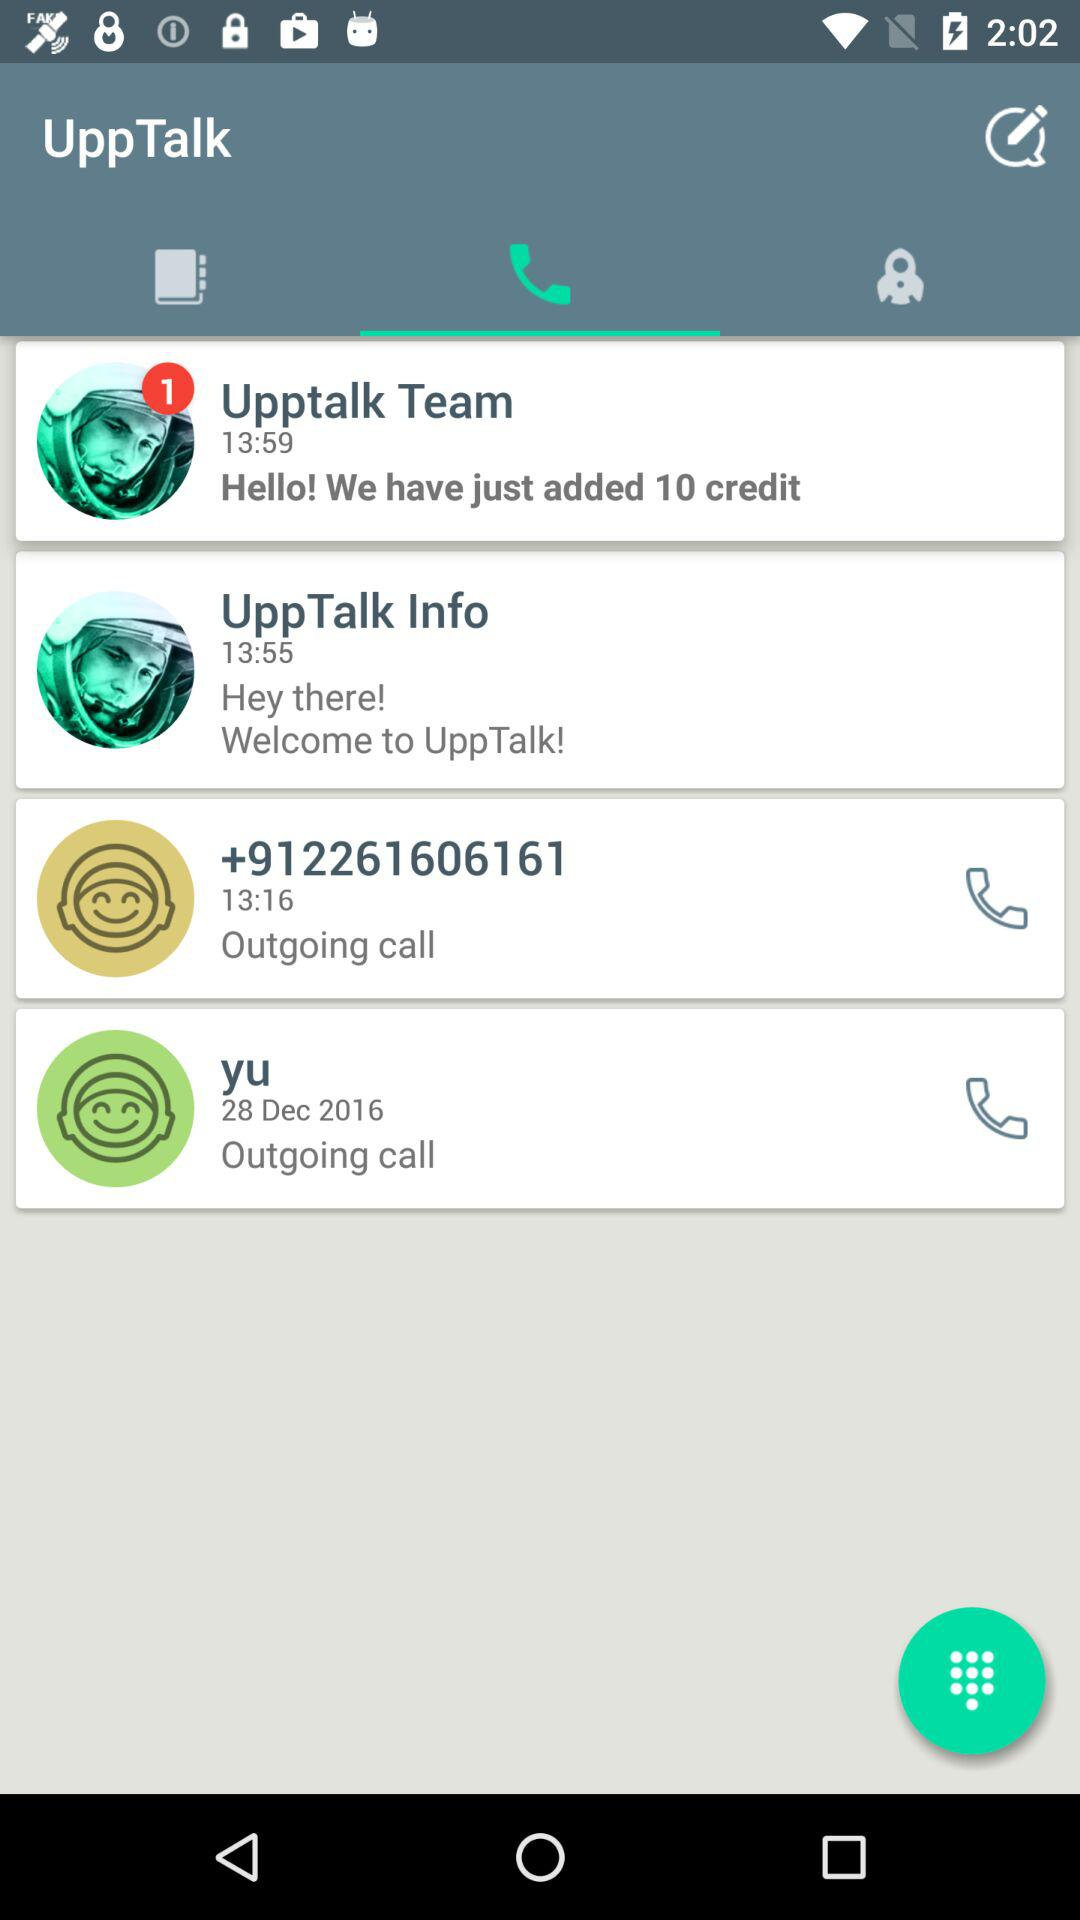What is the name of the application? The name of the application is "UppTalk". 